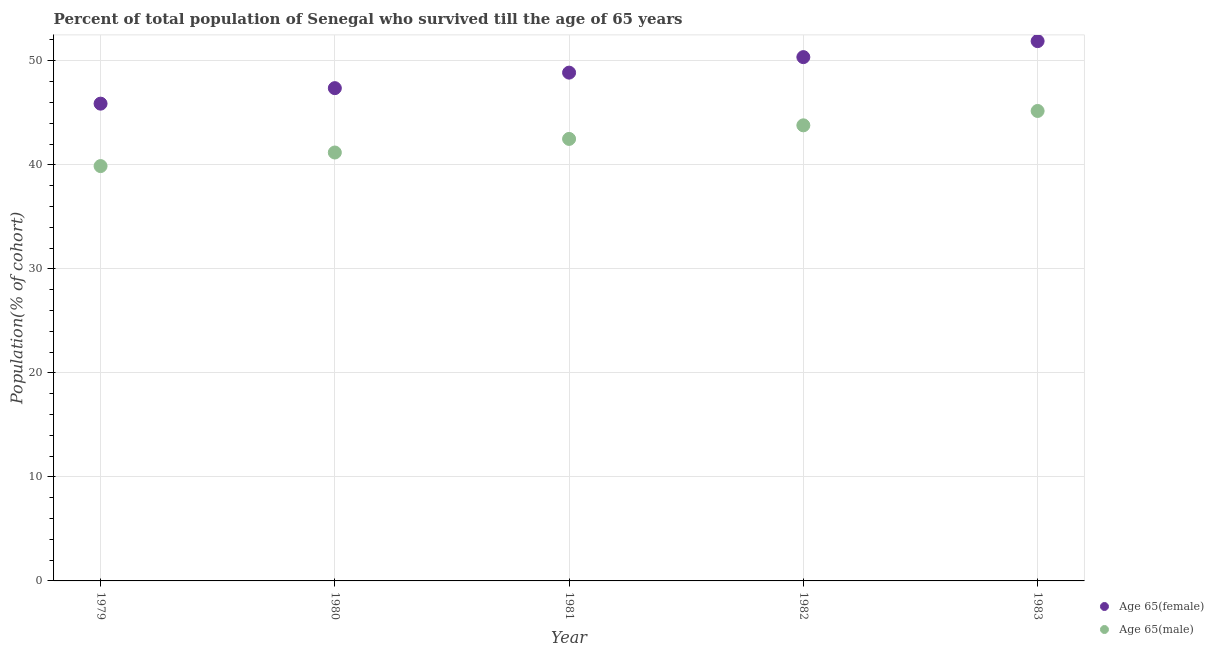Is the number of dotlines equal to the number of legend labels?
Offer a very short reply. Yes. What is the percentage of male population who survived till age of 65 in 1983?
Ensure brevity in your answer.  45.18. Across all years, what is the maximum percentage of female population who survived till age of 65?
Your answer should be very brief. 51.89. Across all years, what is the minimum percentage of male population who survived till age of 65?
Provide a succinct answer. 39.88. In which year was the percentage of female population who survived till age of 65 maximum?
Provide a succinct answer. 1983. In which year was the percentage of female population who survived till age of 65 minimum?
Make the answer very short. 1979. What is the total percentage of female population who survived till age of 65 in the graph?
Ensure brevity in your answer.  244.36. What is the difference between the percentage of male population who survived till age of 65 in 1980 and that in 1982?
Your response must be concise. -2.61. What is the difference between the percentage of female population who survived till age of 65 in 1981 and the percentage of male population who survived till age of 65 in 1980?
Your answer should be compact. 7.68. What is the average percentage of male population who survived till age of 65 per year?
Provide a short and direct response. 42.51. In the year 1982, what is the difference between the percentage of female population who survived till age of 65 and percentage of male population who survived till age of 65?
Provide a succinct answer. 6.56. What is the ratio of the percentage of male population who survived till age of 65 in 1981 to that in 1982?
Keep it short and to the point. 0.97. Is the difference between the percentage of female population who survived till age of 65 in 1979 and 1980 greater than the difference between the percentage of male population who survived till age of 65 in 1979 and 1980?
Make the answer very short. No. What is the difference between the highest and the second highest percentage of male population who survived till age of 65?
Give a very brief answer. 1.38. What is the difference between the highest and the lowest percentage of female population who survived till age of 65?
Make the answer very short. 6.01. In how many years, is the percentage of male population who survived till age of 65 greater than the average percentage of male population who survived till age of 65 taken over all years?
Offer a very short reply. 2. Does the percentage of female population who survived till age of 65 monotonically increase over the years?
Your answer should be very brief. Yes. How many dotlines are there?
Make the answer very short. 2. What is the difference between two consecutive major ticks on the Y-axis?
Give a very brief answer. 10. Are the values on the major ticks of Y-axis written in scientific E-notation?
Offer a very short reply. No. Does the graph contain grids?
Offer a terse response. Yes. Where does the legend appear in the graph?
Provide a short and direct response. Bottom right. How many legend labels are there?
Give a very brief answer. 2. How are the legend labels stacked?
Offer a very short reply. Vertical. What is the title of the graph?
Provide a short and direct response. Percent of total population of Senegal who survived till the age of 65 years. What is the label or title of the Y-axis?
Offer a terse response. Population(% of cohort). What is the Population(% of cohort) of Age 65(female) in 1979?
Provide a short and direct response. 45.88. What is the Population(% of cohort) of Age 65(male) in 1979?
Ensure brevity in your answer.  39.88. What is the Population(% of cohort) in Age 65(female) in 1980?
Your response must be concise. 47.37. What is the Population(% of cohort) in Age 65(male) in 1980?
Your answer should be very brief. 41.18. What is the Population(% of cohort) of Age 65(female) in 1981?
Provide a succinct answer. 48.86. What is the Population(% of cohort) of Age 65(male) in 1981?
Make the answer very short. 42.49. What is the Population(% of cohort) of Age 65(female) in 1982?
Give a very brief answer. 50.35. What is the Population(% of cohort) of Age 65(male) in 1982?
Make the answer very short. 43.8. What is the Population(% of cohort) in Age 65(female) in 1983?
Your answer should be compact. 51.89. What is the Population(% of cohort) of Age 65(male) in 1983?
Provide a short and direct response. 45.18. Across all years, what is the maximum Population(% of cohort) of Age 65(female)?
Provide a succinct answer. 51.89. Across all years, what is the maximum Population(% of cohort) in Age 65(male)?
Make the answer very short. 45.18. Across all years, what is the minimum Population(% of cohort) in Age 65(female)?
Offer a very short reply. 45.88. Across all years, what is the minimum Population(% of cohort) in Age 65(male)?
Provide a short and direct response. 39.88. What is the total Population(% of cohort) of Age 65(female) in the graph?
Give a very brief answer. 244.36. What is the total Population(% of cohort) of Age 65(male) in the graph?
Your answer should be compact. 212.53. What is the difference between the Population(% of cohort) of Age 65(female) in 1979 and that in 1980?
Your response must be concise. -1.49. What is the difference between the Population(% of cohort) of Age 65(male) in 1979 and that in 1980?
Your answer should be very brief. -1.31. What is the difference between the Population(% of cohort) in Age 65(female) in 1979 and that in 1981?
Your answer should be compact. -2.98. What is the difference between the Population(% of cohort) of Age 65(male) in 1979 and that in 1981?
Give a very brief answer. -2.61. What is the difference between the Population(% of cohort) of Age 65(female) in 1979 and that in 1982?
Offer a very short reply. -4.47. What is the difference between the Population(% of cohort) of Age 65(male) in 1979 and that in 1982?
Keep it short and to the point. -3.92. What is the difference between the Population(% of cohort) in Age 65(female) in 1979 and that in 1983?
Provide a short and direct response. -6.01. What is the difference between the Population(% of cohort) in Age 65(male) in 1979 and that in 1983?
Keep it short and to the point. -5.3. What is the difference between the Population(% of cohort) in Age 65(female) in 1980 and that in 1981?
Provide a short and direct response. -1.49. What is the difference between the Population(% of cohort) in Age 65(male) in 1980 and that in 1981?
Ensure brevity in your answer.  -1.31. What is the difference between the Population(% of cohort) in Age 65(female) in 1980 and that in 1982?
Your response must be concise. -2.98. What is the difference between the Population(% of cohort) in Age 65(male) in 1980 and that in 1982?
Your response must be concise. -2.61. What is the difference between the Population(% of cohort) of Age 65(female) in 1980 and that in 1983?
Offer a terse response. -4.52. What is the difference between the Population(% of cohort) in Age 65(male) in 1980 and that in 1983?
Your response must be concise. -3.99. What is the difference between the Population(% of cohort) of Age 65(female) in 1981 and that in 1982?
Offer a terse response. -1.49. What is the difference between the Population(% of cohort) in Age 65(male) in 1981 and that in 1982?
Ensure brevity in your answer.  -1.31. What is the difference between the Population(% of cohort) of Age 65(female) in 1981 and that in 1983?
Offer a very short reply. -3.03. What is the difference between the Population(% of cohort) in Age 65(male) in 1981 and that in 1983?
Provide a short and direct response. -2.69. What is the difference between the Population(% of cohort) of Age 65(female) in 1982 and that in 1983?
Your response must be concise. -1.54. What is the difference between the Population(% of cohort) of Age 65(male) in 1982 and that in 1983?
Provide a short and direct response. -1.38. What is the difference between the Population(% of cohort) of Age 65(female) in 1979 and the Population(% of cohort) of Age 65(male) in 1980?
Your answer should be very brief. 4.7. What is the difference between the Population(% of cohort) of Age 65(female) in 1979 and the Population(% of cohort) of Age 65(male) in 1981?
Provide a short and direct response. 3.39. What is the difference between the Population(% of cohort) of Age 65(female) in 1979 and the Population(% of cohort) of Age 65(male) in 1982?
Make the answer very short. 2.08. What is the difference between the Population(% of cohort) of Age 65(female) in 1979 and the Population(% of cohort) of Age 65(male) in 1983?
Your answer should be very brief. 0.7. What is the difference between the Population(% of cohort) of Age 65(female) in 1980 and the Population(% of cohort) of Age 65(male) in 1981?
Provide a succinct answer. 4.88. What is the difference between the Population(% of cohort) of Age 65(female) in 1980 and the Population(% of cohort) of Age 65(male) in 1982?
Provide a succinct answer. 3.57. What is the difference between the Population(% of cohort) of Age 65(female) in 1980 and the Population(% of cohort) of Age 65(male) in 1983?
Offer a very short reply. 2.19. What is the difference between the Population(% of cohort) in Age 65(female) in 1981 and the Population(% of cohort) in Age 65(male) in 1982?
Your answer should be compact. 5.07. What is the difference between the Population(% of cohort) of Age 65(female) in 1981 and the Population(% of cohort) of Age 65(male) in 1983?
Keep it short and to the point. 3.68. What is the difference between the Population(% of cohort) of Age 65(female) in 1982 and the Population(% of cohort) of Age 65(male) in 1983?
Offer a very short reply. 5.18. What is the average Population(% of cohort) of Age 65(female) per year?
Keep it short and to the point. 48.87. What is the average Population(% of cohort) of Age 65(male) per year?
Give a very brief answer. 42.51. In the year 1979, what is the difference between the Population(% of cohort) in Age 65(female) and Population(% of cohort) in Age 65(male)?
Your answer should be very brief. 6. In the year 1980, what is the difference between the Population(% of cohort) in Age 65(female) and Population(% of cohort) in Age 65(male)?
Your answer should be compact. 6.19. In the year 1981, what is the difference between the Population(% of cohort) of Age 65(female) and Population(% of cohort) of Age 65(male)?
Offer a terse response. 6.37. In the year 1982, what is the difference between the Population(% of cohort) in Age 65(female) and Population(% of cohort) in Age 65(male)?
Your answer should be very brief. 6.56. In the year 1983, what is the difference between the Population(% of cohort) in Age 65(female) and Population(% of cohort) in Age 65(male)?
Keep it short and to the point. 6.71. What is the ratio of the Population(% of cohort) in Age 65(female) in 1979 to that in 1980?
Provide a succinct answer. 0.97. What is the ratio of the Population(% of cohort) of Age 65(male) in 1979 to that in 1980?
Your response must be concise. 0.97. What is the ratio of the Population(% of cohort) in Age 65(female) in 1979 to that in 1981?
Make the answer very short. 0.94. What is the ratio of the Population(% of cohort) in Age 65(male) in 1979 to that in 1981?
Your answer should be compact. 0.94. What is the ratio of the Population(% of cohort) in Age 65(female) in 1979 to that in 1982?
Provide a short and direct response. 0.91. What is the ratio of the Population(% of cohort) of Age 65(male) in 1979 to that in 1982?
Your response must be concise. 0.91. What is the ratio of the Population(% of cohort) in Age 65(female) in 1979 to that in 1983?
Your answer should be very brief. 0.88. What is the ratio of the Population(% of cohort) of Age 65(male) in 1979 to that in 1983?
Make the answer very short. 0.88. What is the ratio of the Population(% of cohort) in Age 65(female) in 1980 to that in 1981?
Make the answer very short. 0.97. What is the ratio of the Population(% of cohort) in Age 65(male) in 1980 to that in 1981?
Provide a short and direct response. 0.97. What is the ratio of the Population(% of cohort) of Age 65(female) in 1980 to that in 1982?
Your response must be concise. 0.94. What is the ratio of the Population(% of cohort) of Age 65(male) in 1980 to that in 1982?
Provide a succinct answer. 0.94. What is the ratio of the Population(% of cohort) of Age 65(female) in 1980 to that in 1983?
Ensure brevity in your answer.  0.91. What is the ratio of the Population(% of cohort) in Age 65(male) in 1980 to that in 1983?
Keep it short and to the point. 0.91. What is the ratio of the Population(% of cohort) in Age 65(female) in 1981 to that in 1982?
Make the answer very short. 0.97. What is the ratio of the Population(% of cohort) of Age 65(male) in 1981 to that in 1982?
Offer a terse response. 0.97. What is the ratio of the Population(% of cohort) of Age 65(female) in 1981 to that in 1983?
Provide a short and direct response. 0.94. What is the ratio of the Population(% of cohort) of Age 65(male) in 1981 to that in 1983?
Ensure brevity in your answer.  0.94. What is the ratio of the Population(% of cohort) in Age 65(female) in 1982 to that in 1983?
Provide a succinct answer. 0.97. What is the ratio of the Population(% of cohort) of Age 65(male) in 1982 to that in 1983?
Your answer should be very brief. 0.97. What is the difference between the highest and the second highest Population(% of cohort) in Age 65(female)?
Your answer should be very brief. 1.54. What is the difference between the highest and the second highest Population(% of cohort) in Age 65(male)?
Your response must be concise. 1.38. What is the difference between the highest and the lowest Population(% of cohort) of Age 65(female)?
Provide a short and direct response. 6.01. What is the difference between the highest and the lowest Population(% of cohort) in Age 65(male)?
Offer a very short reply. 5.3. 